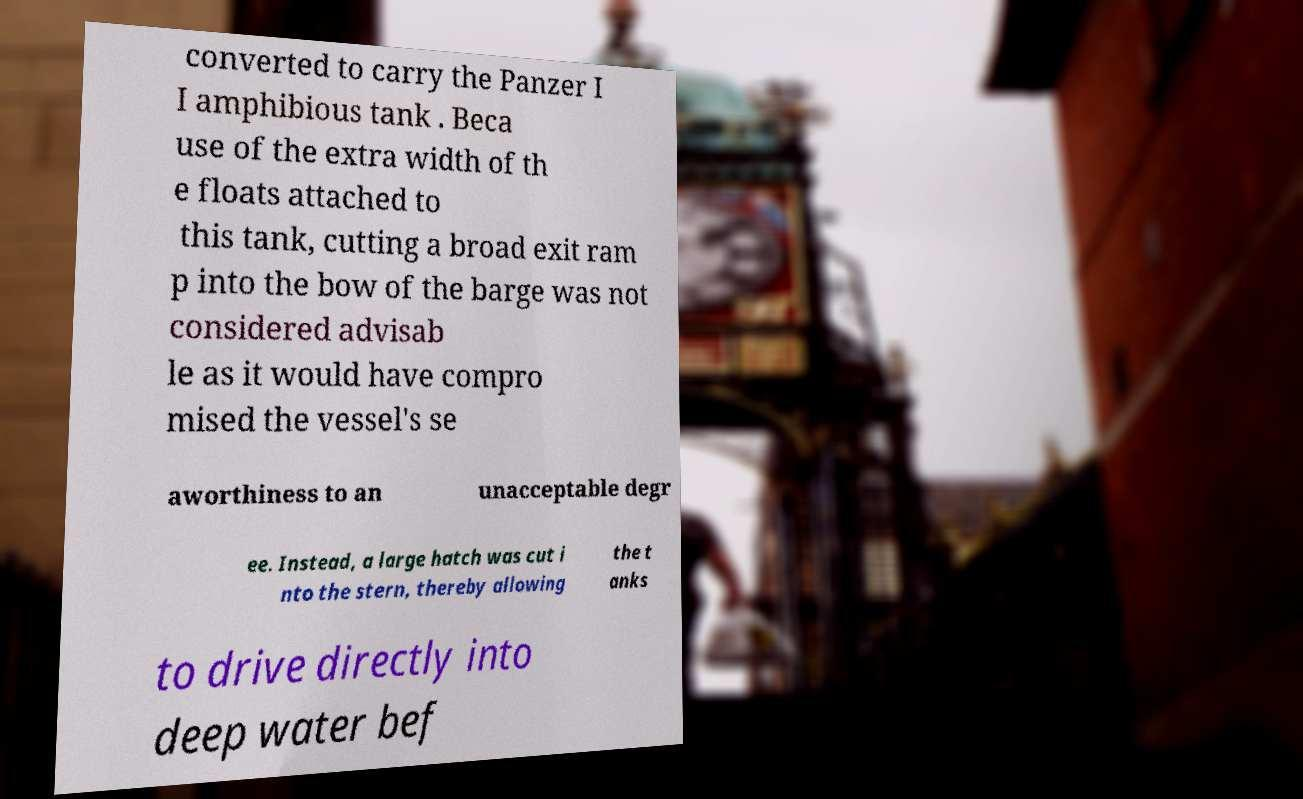Could you extract and type out the text from this image? converted to carry the Panzer I I amphibious tank . Beca use of the extra width of th e floats attached to this tank, cutting a broad exit ram p into the bow of the barge was not considered advisab le as it would have compro mised the vessel's se aworthiness to an unacceptable degr ee. Instead, a large hatch was cut i nto the stern, thereby allowing the t anks to drive directly into deep water bef 